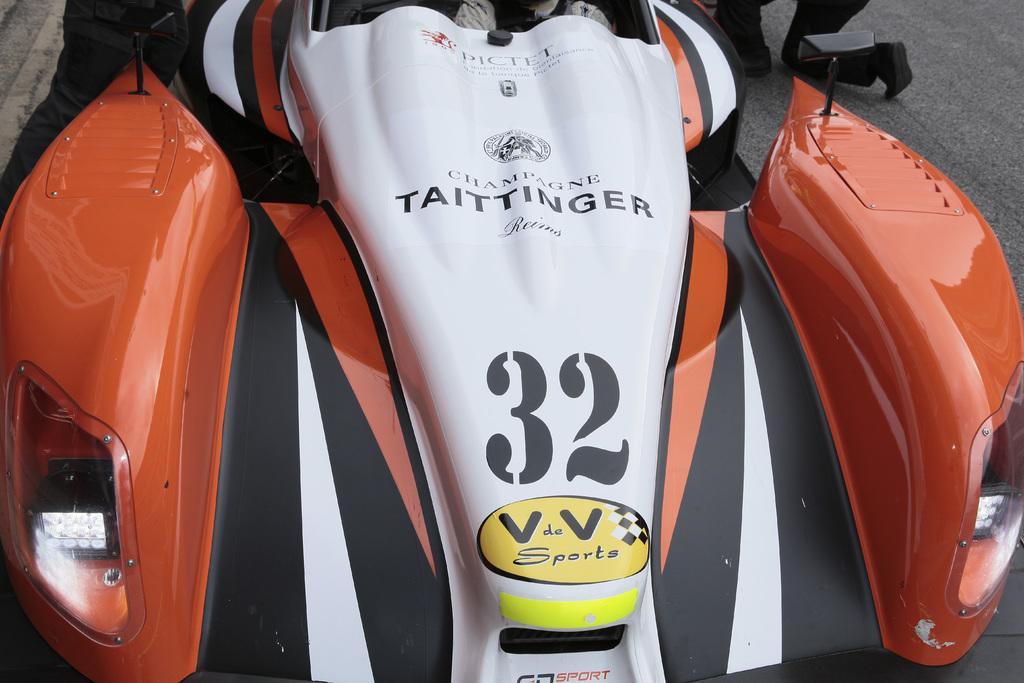Describe this image in one or two sentences. In this picture there is a vehicle on the road and there are two persons on the road. 